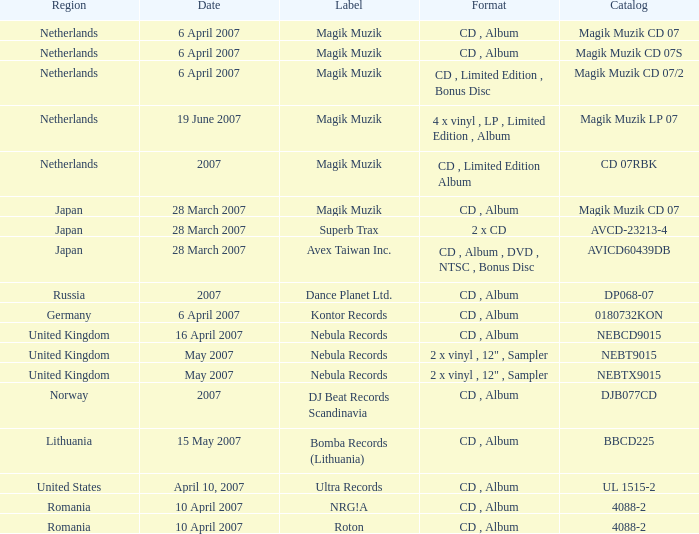Which music label published the catalog magik muzik cd 07 on 28 march 2007? Magik Muzik. 